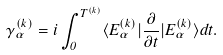<formula> <loc_0><loc_0><loc_500><loc_500>\gamma _ { \alpha } ^ { ( k ) } = i \int _ { 0 } ^ { T ^ { ( k ) } } \langle E _ { \alpha } ^ { ( k ) } | \frac { \partial } { \partial t } | E _ { \alpha } ^ { ( k ) } \rangle d t .</formula> 